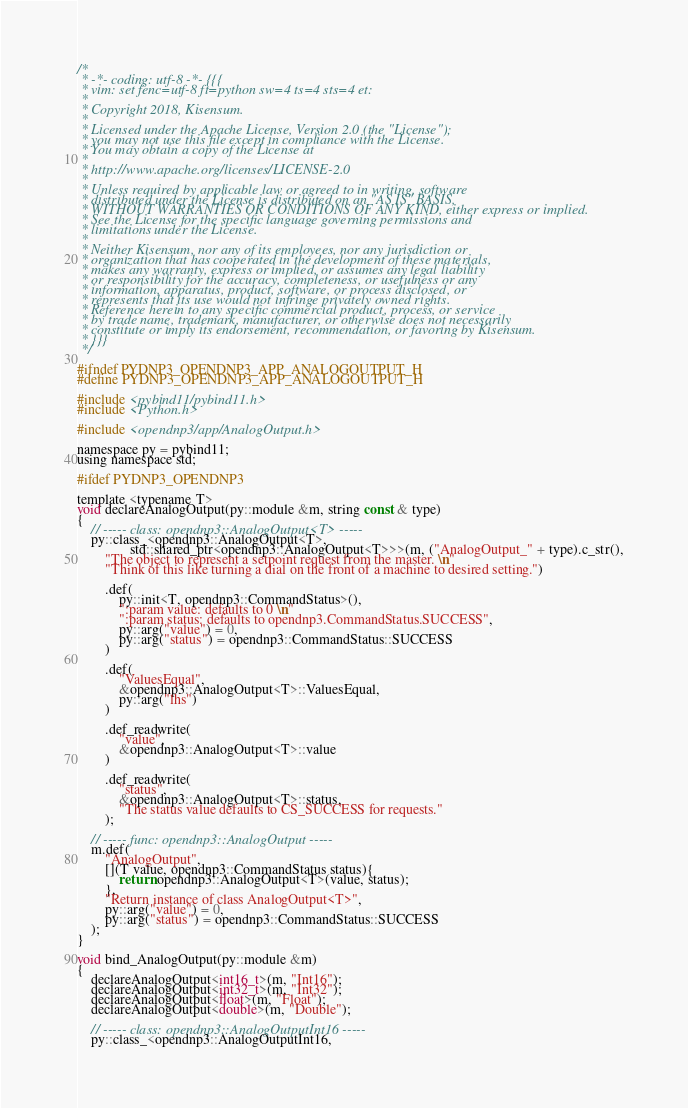<code> <loc_0><loc_0><loc_500><loc_500><_C_>/*
 * -*- coding: utf-8 -*- {{{
 * vim: set fenc=utf-8 ft=python sw=4 ts=4 sts=4 et:
 *
 * Copyright 2018, Kisensum.
 *
 * Licensed under the Apache License, Version 2.0 (the "License");
 * you may not use this file except in compliance with the License.
 * You may obtain a copy of the License at
 *
 * http://www.apache.org/licenses/LICENSE-2.0
 *
 * Unless required by applicable law or agreed to in writing, software
 * distributed under the License is distributed on an "AS IS" BASIS,
 * WITHOUT WARRANTIES OR CONDITIONS OF ANY KIND, either express or implied.
 * See the License for the specific language governing permissions and
 * limitations under the License.
 *
 * Neither Kisensum, nor any of its employees, nor any jurisdiction or
 * organization that has cooperated in the development of these materials,
 * makes any warranty, express or implied, or assumes any legal liability
 * or responsibility for the accuracy, completeness, or usefulness or any
 * information, apparatus, product, software, or process disclosed, or
 * represents that its use would not infringe privately owned rights.
 * Reference herein to any specific commercial product, process, or service
 * by trade name, trademark, manufacturer, or otherwise does not necessarily
 * constitute or imply its endorsement, recommendation, or favoring by Kisensum.
 * }}}
 */

#ifndef PYDNP3_OPENDNP3_APP_ANALOGOUTPUT_H
#define PYDNP3_OPENDNP3_APP_ANALOGOUTPUT_H

#include <pybind11/pybind11.h>
#include <Python.h>

#include <opendnp3/app/AnalogOutput.h>

namespace py = pybind11;
using namespace std;

#ifdef PYDNP3_OPENDNP3

template <typename T>
void declareAnalogOutput(py::module &m, string const & type)
{
    // ----- class: opendnp3::AnalogOutput<T> -----
    py::class_<opendnp3::AnalogOutput<T>,
               std::shared_ptr<opendnp3::AnalogOutput<T>>>(m, ("AnalogOutput_" + type).c_str(),
        "The object to represent a setpoint request from the master. \n"
        "Think of this like turning a dial on the front of a machine to desired setting.")

        .def(
            py::init<T, opendnp3::CommandStatus>(),
            ":param value: defaults to 0 \n"
            ":param status: defaults to opendnp3.CommandStatus.SUCCESS",
            py::arg("value") = 0,
            py::arg("status") = opendnp3::CommandStatus::SUCCESS
        )

        .def(
            "ValuesEqual",
            &opendnp3::AnalogOutput<T>::ValuesEqual,
            py::arg("lhs")
        )

        .def_readwrite(
            "value",
            &opendnp3::AnalogOutput<T>::value
        )

        .def_readwrite(
            "status",
            &opendnp3::AnalogOutput<T>::status,
            "The status value defaults to CS_SUCCESS for requests."
        );

    // ----- func: opendnp3::AnalogOutput -----
    m.def(
        "AnalogOutput",
        [](T value, opendnp3::CommandStatus status){
            return opendnp3::AnalogOutput<T>(value, status);
        },
        "Return instance of class AnalogOutput<T>",
        py::arg("value") = 0,
        py::arg("status") = opendnp3::CommandStatus::SUCCESS
    );
}

void bind_AnalogOutput(py::module &m)
{
    declareAnalogOutput<int16_t>(m, "Int16");
    declareAnalogOutput<int32_t>(m, "Int32");
    declareAnalogOutput<float>(m, "Float");
    declareAnalogOutput<double>(m, "Double");

    // ----- class: opendnp3::AnalogOutputInt16 -----  
    py::class_<opendnp3::AnalogOutputInt16,</code> 